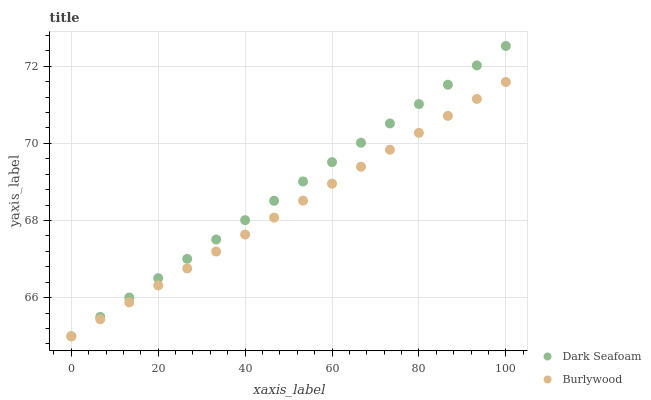Does Burlywood have the minimum area under the curve?
Answer yes or no. Yes. Does Dark Seafoam have the maximum area under the curve?
Answer yes or no. Yes. Does Dark Seafoam have the minimum area under the curve?
Answer yes or no. No. Is Burlywood the smoothest?
Answer yes or no. Yes. Is Dark Seafoam the roughest?
Answer yes or no. Yes. Is Dark Seafoam the smoothest?
Answer yes or no. No. Does Burlywood have the lowest value?
Answer yes or no. Yes. Does Dark Seafoam have the highest value?
Answer yes or no. Yes. Does Dark Seafoam intersect Burlywood?
Answer yes or no. Yes. Is Dark Seafoam less than Burlywood?
Answer yes or no. No. Is Dark Seafoam greater than Burlywood?
Answer yes or no. No. 